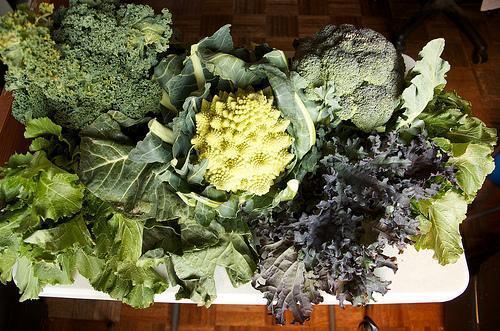How many chairs are there?
Give a very brief answer. 1. 